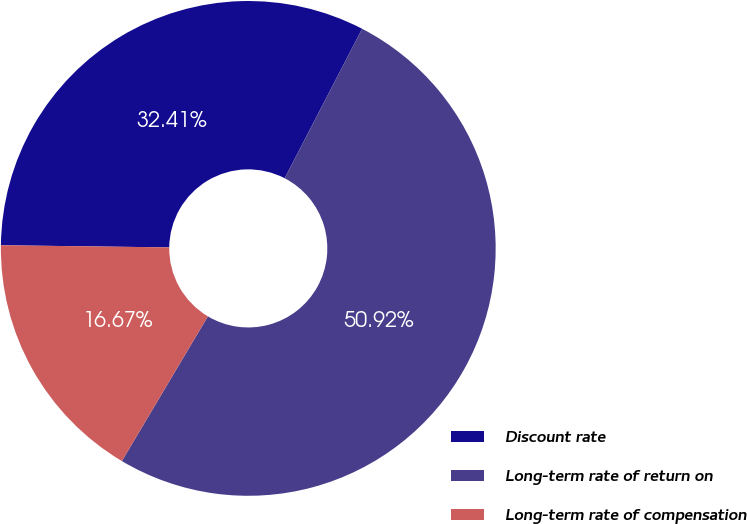<chart> <loc_0><loc_0><loc_500><loc_500><pie_chart><fcel>Discount rate<fcel>Long-term rate of return on<fcel>Long-term rate of compensation<nl><fcel>32.41%<fcel>50.93%<fcel>16.67%<nl></chart> 